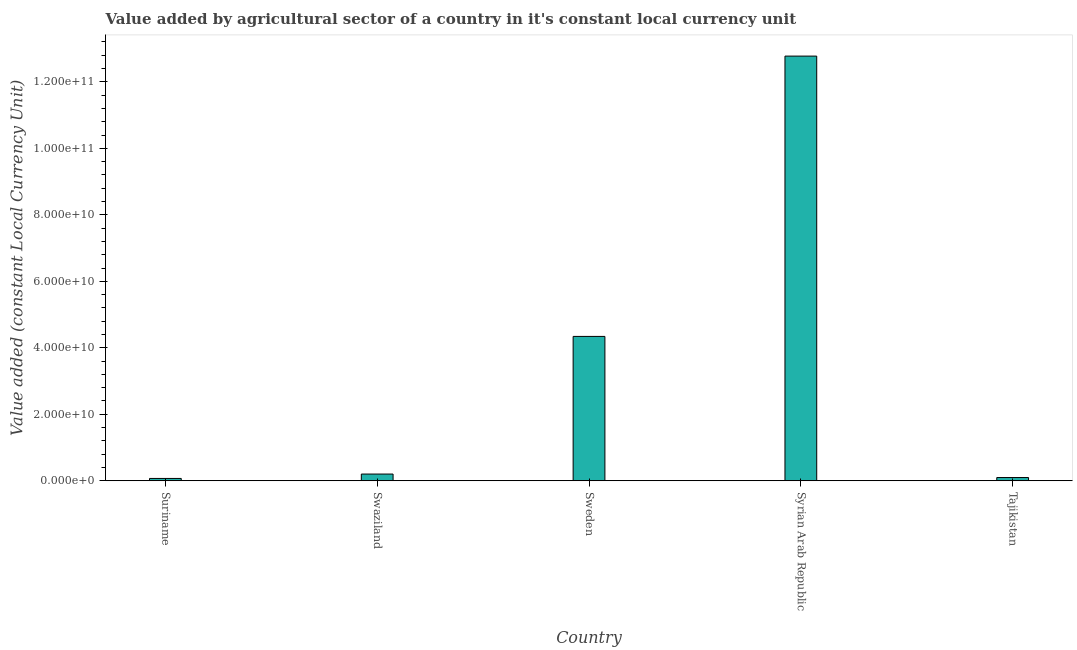What is the title of the graph?
Keep it short and to the point. Value added by agricultural sector of a country in it's constant local currency unit. What is the label or title of the X-axis?
Your answer should be very brief. Country. What is the label or title of the Y-axis?
Offer a very short reply. Value added (constant Local Currency Unit). What is the value added by agriculture sector in Tajikistan?
Offer a terse response. 9.78e+08. Across all countries, what is the maximum value added by agriculture sector?
Provide a short and direct response. 1.28e+11. Across all countries, what is the minimum value added by agriculture sector?
Offer a very short reply. 7.03e+08. In which country was the value added by agriculture sector maximum?
Your answer should be very brief. Syrian Arab Republic. In which country was the value added by agriculture sector minimum?
Make the answer very short. Suriname. What is the sum of the value added by agriculture sector?
Provide a succinct answer. 1.75e+11. What is the difference between the value added by agriculture sector in Sweden and Syrian Arab Republic?
Offer a terse response. -8.43e+1. What is the average value added by agriculture sector per country?
Make the answer very short. 3.50e+1. What is the median value added by agriculture sector?
Your answer should be compact. 2.03e+09. What is the ratio of the value added by agriculture sector in Syrian Arab Republic to that in Tajikistan?
Keep it short and to the point. 130.64. Is the value added by agriculture sector in Swaziland less than that in Sweden?
Offer a very short reply. Yes. Is the difference between the value added by agriculture sector in Swaziland and Tajikistan greater than the difference between any two countries?
Make the answer very short. No. What is the difference between the highest and the second highest value added by agriculture sector?
Your response must be concise. 8.43e+1. Is the sum of the value added by agriculture sector in Suriname and Swaziland greater than the maximum value added by agriculture sector across all countries?
Your answer should be compact. No. What is the difference between the highest and the lowest value added by agriculture sector?
Your answer should be compact. 1.27e+11. In how many countries, is the value added by agriculture sector greater than the average value added by agriculture sector taken over all countries?
Give a very brief answer. 2. How many bars are there?
Make the answer very short. 5. Are all the bars in the graph horizontal?
Your answer should be very brief. No. What is the difference between two consecutive major ticks on the Y-axis?
Your response must be concise. 2.00e+1. What is the Value added (constant Local Currency Unit) in Suriname?
Keep it short and to the point. 7.03e+08. What is the Value added (constant Local Currency Unit) of Swaziland?
Offer a very short reply. 2.03e+09. What is the Value added (constant Local Currency Unit) in Sweden?
Make the answer very short. 4.34e+1. What is the Value added (constant Local Currency Unit) in Syrian Arab Republic?
Ensure brevity in your answer.  1.28e+11. What is the Value added (constant Local Currency Unit) in Tajikistan?
Your answer should be very brief. 9.78e+08. What is the difference between the Value added (constant Local Currency Unit) in Suriname and Swaziland?
Your answer should be compact. -1.32e+09. What is the difference between the Value added (constant Local Currency Unit) in Suriname and Sweden?
Give a very brief answer. -4.27e+1. What is the difference between the Value added (constant Local Currency Unit) in Suriname and Syrian Arab Republic?
Offer a terse response. -1.27e+11. What is the difference between the Value added (constant Local Currency Unit) in Suriname and Tajikistan?
Give a very brief answer. -2.74e+08. What is the difference between the Value added (constant Local Currency Unit) in Swaziland and Sweden?
Provide a short and direct response. -4.14e+1. What is the difference between the Value added (constant Local Currency Unit) in Swaziland and Syrian Arab Republic?
Offer a terse response. -1.26e+11. What is the difference between the Value added (constant Local Currency Unit) in Swaziland and Tajikistan?
Your response must be concise. 1.05e+09. What is the difference between the Value added (constant Local Currency Unit) in Sweden and Syrian Arab Republic?
Your answer should be very brief. -8.43e+1. What is the difference between the Value added (constant Local Currency Unit) in Sweden and Tajikistan?
Your answer should be very brief. 4.24e+1. What is the difference between the Value added (constant Local Currency Unit) in Syrian Arab Republic and Tajikistan?
Provide a succinct answer. 1.27e+11. What is the ratio of the Value added (constant Local Currency Unit) in Suriname to that in Swaziland?
Offer a very short reply. 0.35. What is the ratio of the Value added (constant Local Currency Unit) in Suriname to that in Sweden?
Keep it short and to the point. 0.02. What is the ratio of the Value added (constant Local Currency Unit) in Suriname to that in Syrian Arab Republic?
Ensure brevity in your answer.  0.01. What is the ratio of the Value added (constant Local Currency Unit) in Suriname to that in Tajikistan?
Provide a short and direct response. 0.72. What is the ratio of the Value added (constant Local Currency Unit) in Swaziland to that in Sweden?
Provide a succinct answer. 0.05. What is the ratio of the Value added (constant Local Currency Unit) in Swaziland to that in Syrian Arab Republic?
Give a very brief answer. 0.02. What is the ratio of the Value added (constant Local Currency Unit) in Swaziland to that in Tajikistan?
Give a very brief answer. 2.07. What is the ratio of the Value added (constant Local Currency Unit) in Sweden to that in Syrian Arab Republic?
Your answer should be very brief. 0.34. What is the ratio of the Value added (constant Local Currency Unit) in Sweden to that in Tajikistan?
Give a very brief answer. 44.41. What is the ratio of the Value added (constant Local Currency Unit) in Syrian Arab Republic to that in Tajikistan?
Your answer should be very brief. 130.64. 